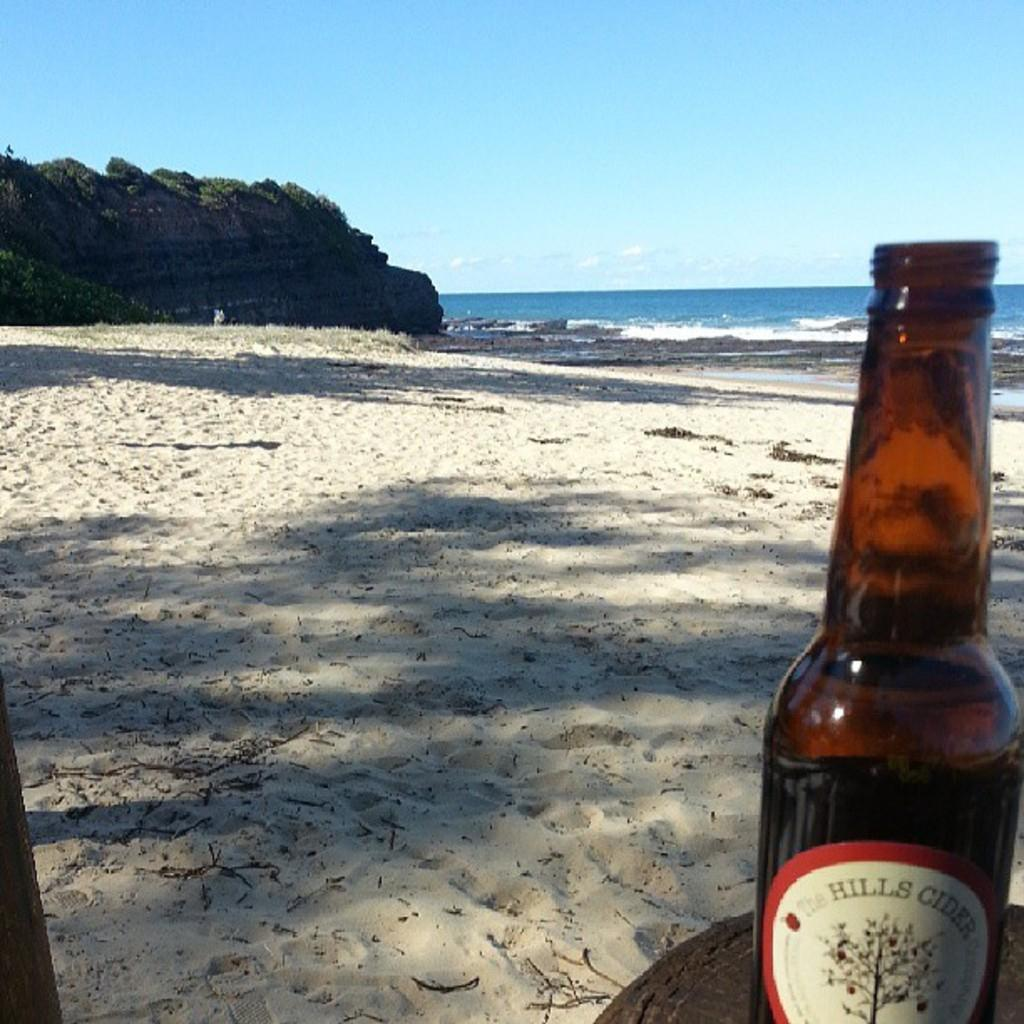<image>
Create a compact narrative representing the image presented. A bottle of Hill's cider is on the beach. 